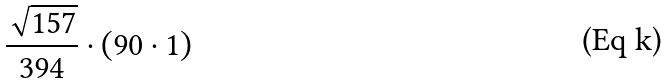<formula> <loc_0><loc_0><loc_500><loc_500>\frac { \sqrt { 1 5 7 } } { 3 9 4 } \cdot ( 9 0 \cdot 1 )</formula> 